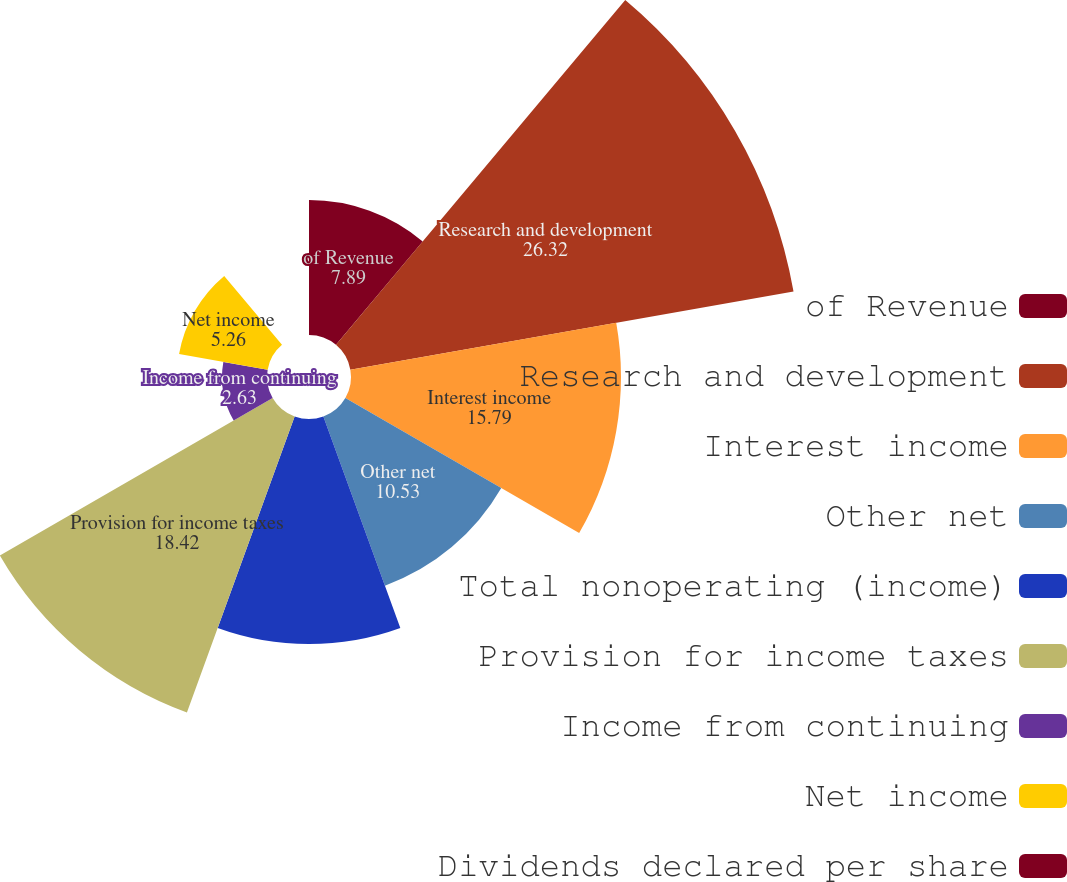<chart> <loc_0><loc_0><loc_500><loc_500><pie_chart><fcel>of Revenue<fcel>Research and development<fcel>Interest income<fcel>Other net<fcel>Total nonoperating (income)<fcel>Provision for income taxes<fcel>Income from continuing<fcel>Net income<fcel>Dividends declared per share<nl><fcel>7.89%<fcel>26.32%<fcel>15.79%<fcel>10.53%<fcel>13.16%<fcel>18.42%<fcel>2.63%<fcel>5.26%<fcel>0.0%<nl></chart> 